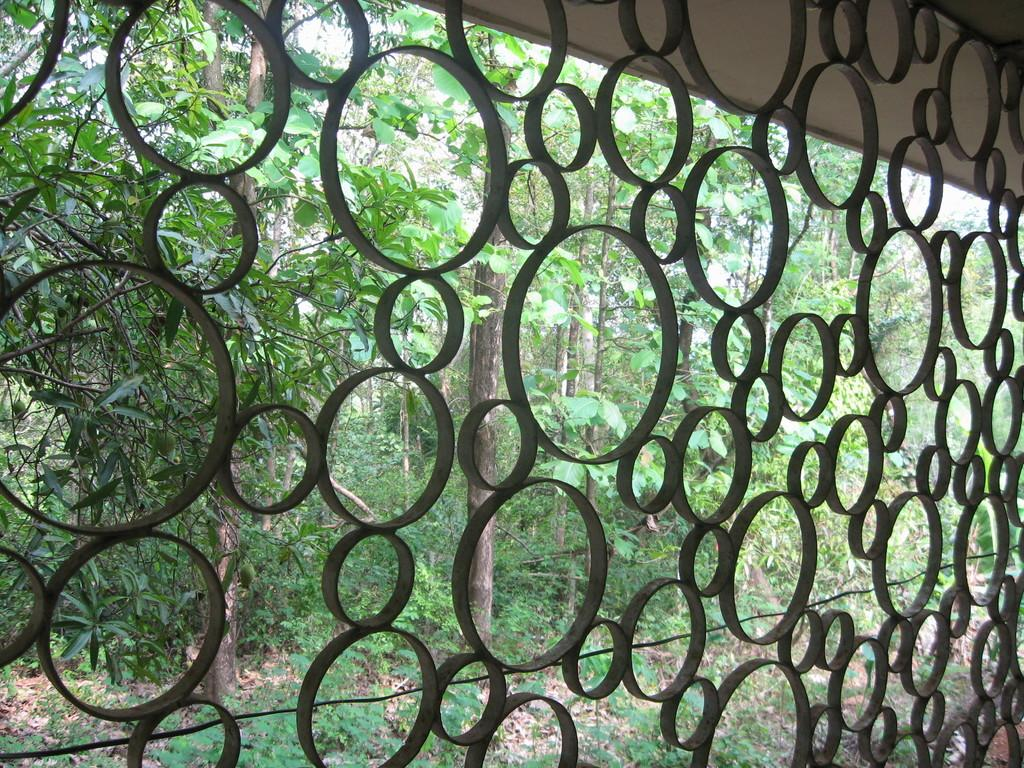What is the main feature of the image? The main feature of the image is the grill of a window. What can be seen through the window? Many trees are visible through the window. What grade is the produce being given in the image? There is no produce or grading system present in the image; it only features a window grill and trees visible through the window. 